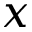Convert formula to latex. <formula><loc_0><loc_0><loc_500><loc_500>x</formula> 